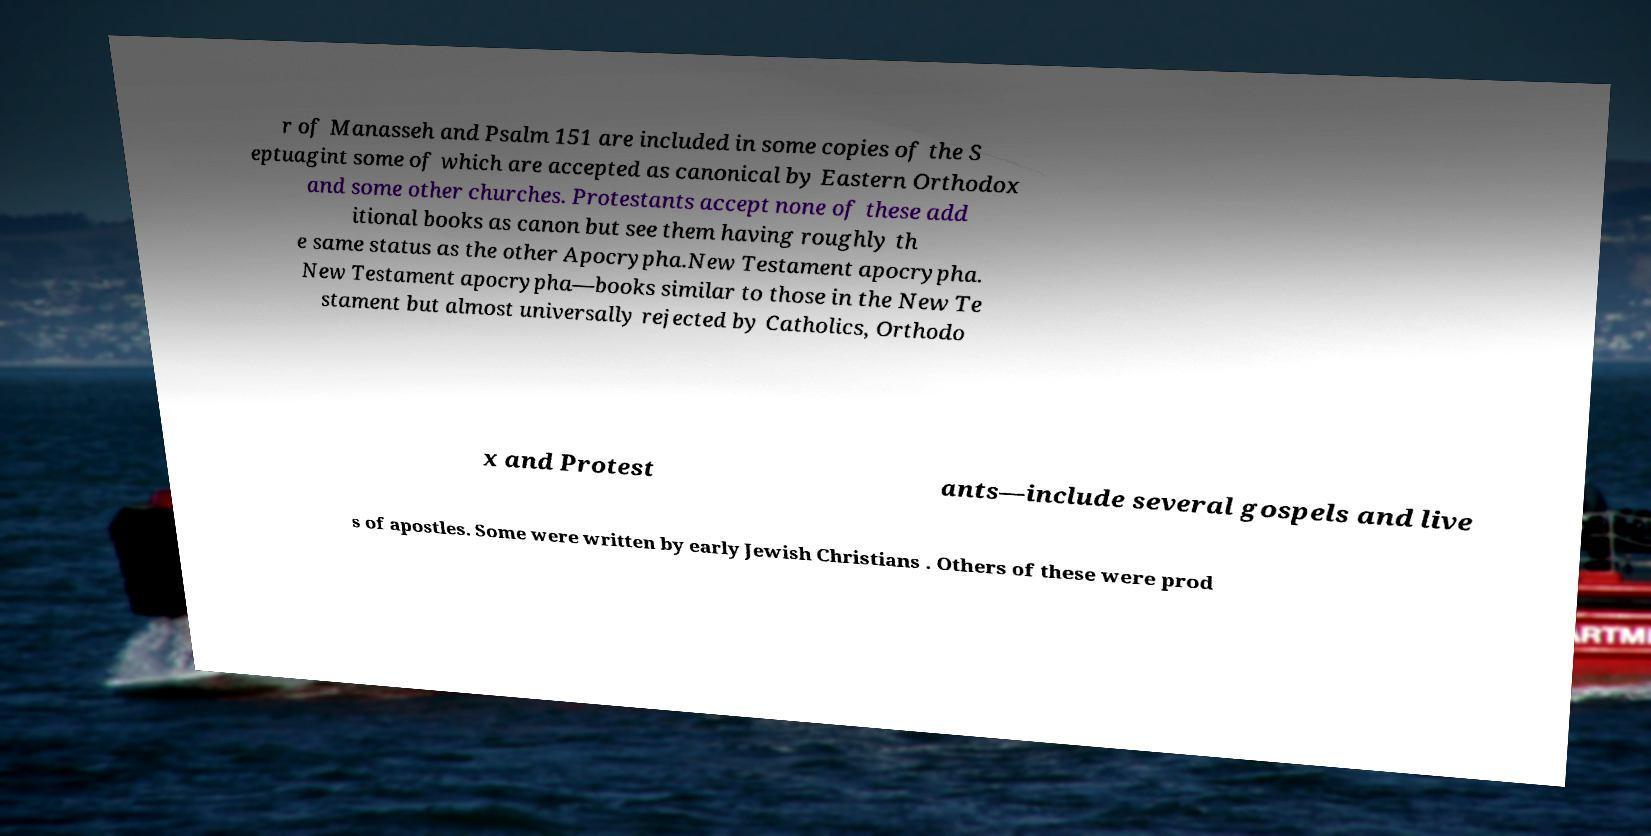Could you assist in decoding the text presented in this image and type it out clearly? r of Manasseh and Psalm 151 are included in some copies of the S eptuagint some of which are accepted as canonical by Eastern Orthodox and some other churches. Protestants accept none of these add itional books as canon but see them having roughly th e same status as the other Apocrypha.New Testament apocrypha. New Testament apocrypha—books similar to those in the New Te stament but almost universally rejected by Catholics, Orthodo x and Protest ants—include several gospels and live s of apostles. Some were written by early Jewish Christians . Others of these were prod 